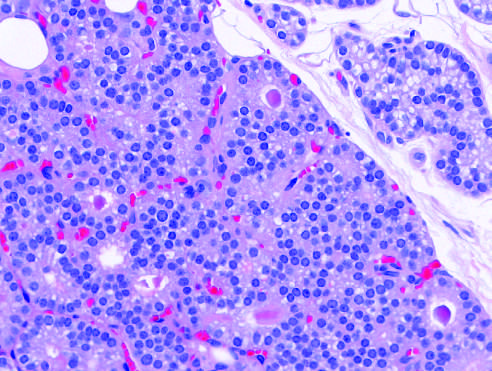what shows minimal variation in nuclear size and occasional follicle formation?
Answer the question using a single word or phrase. High-power detail 